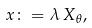Convert formula to latex. <formula><loc_0><loc_0><loc_500><loc_500>x \colon = \lambda \, X _ { \theta } ,</formula> 